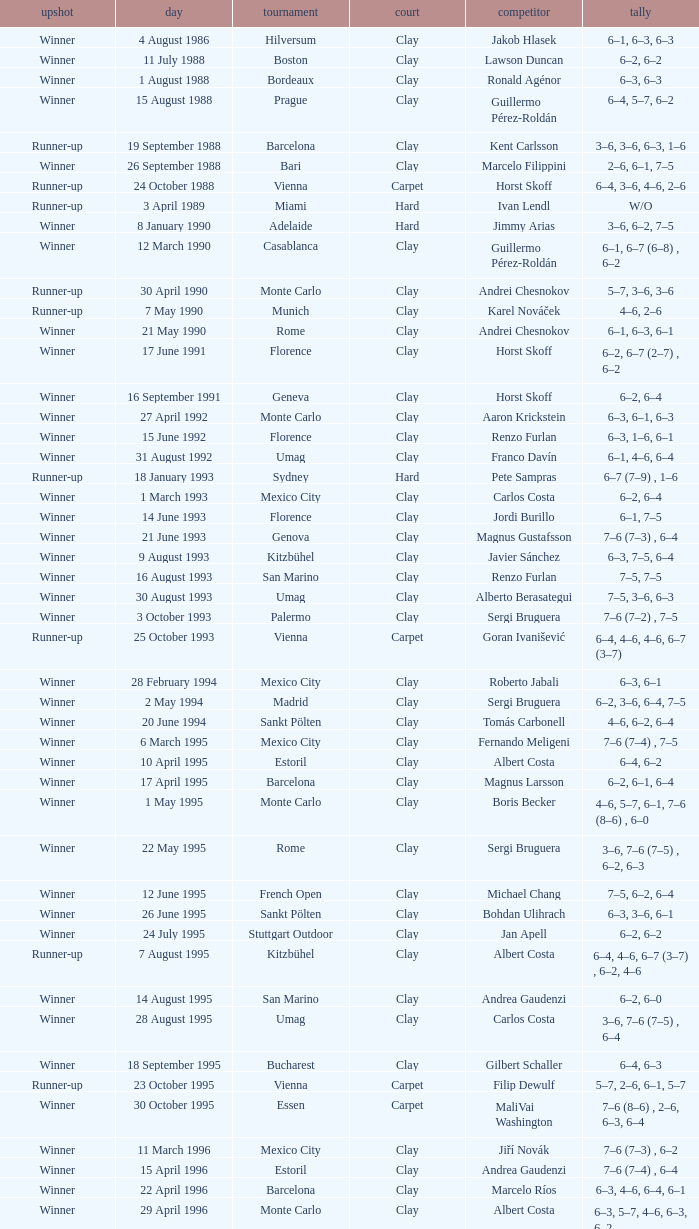What is the surface on 21 june 1993? Clay. 